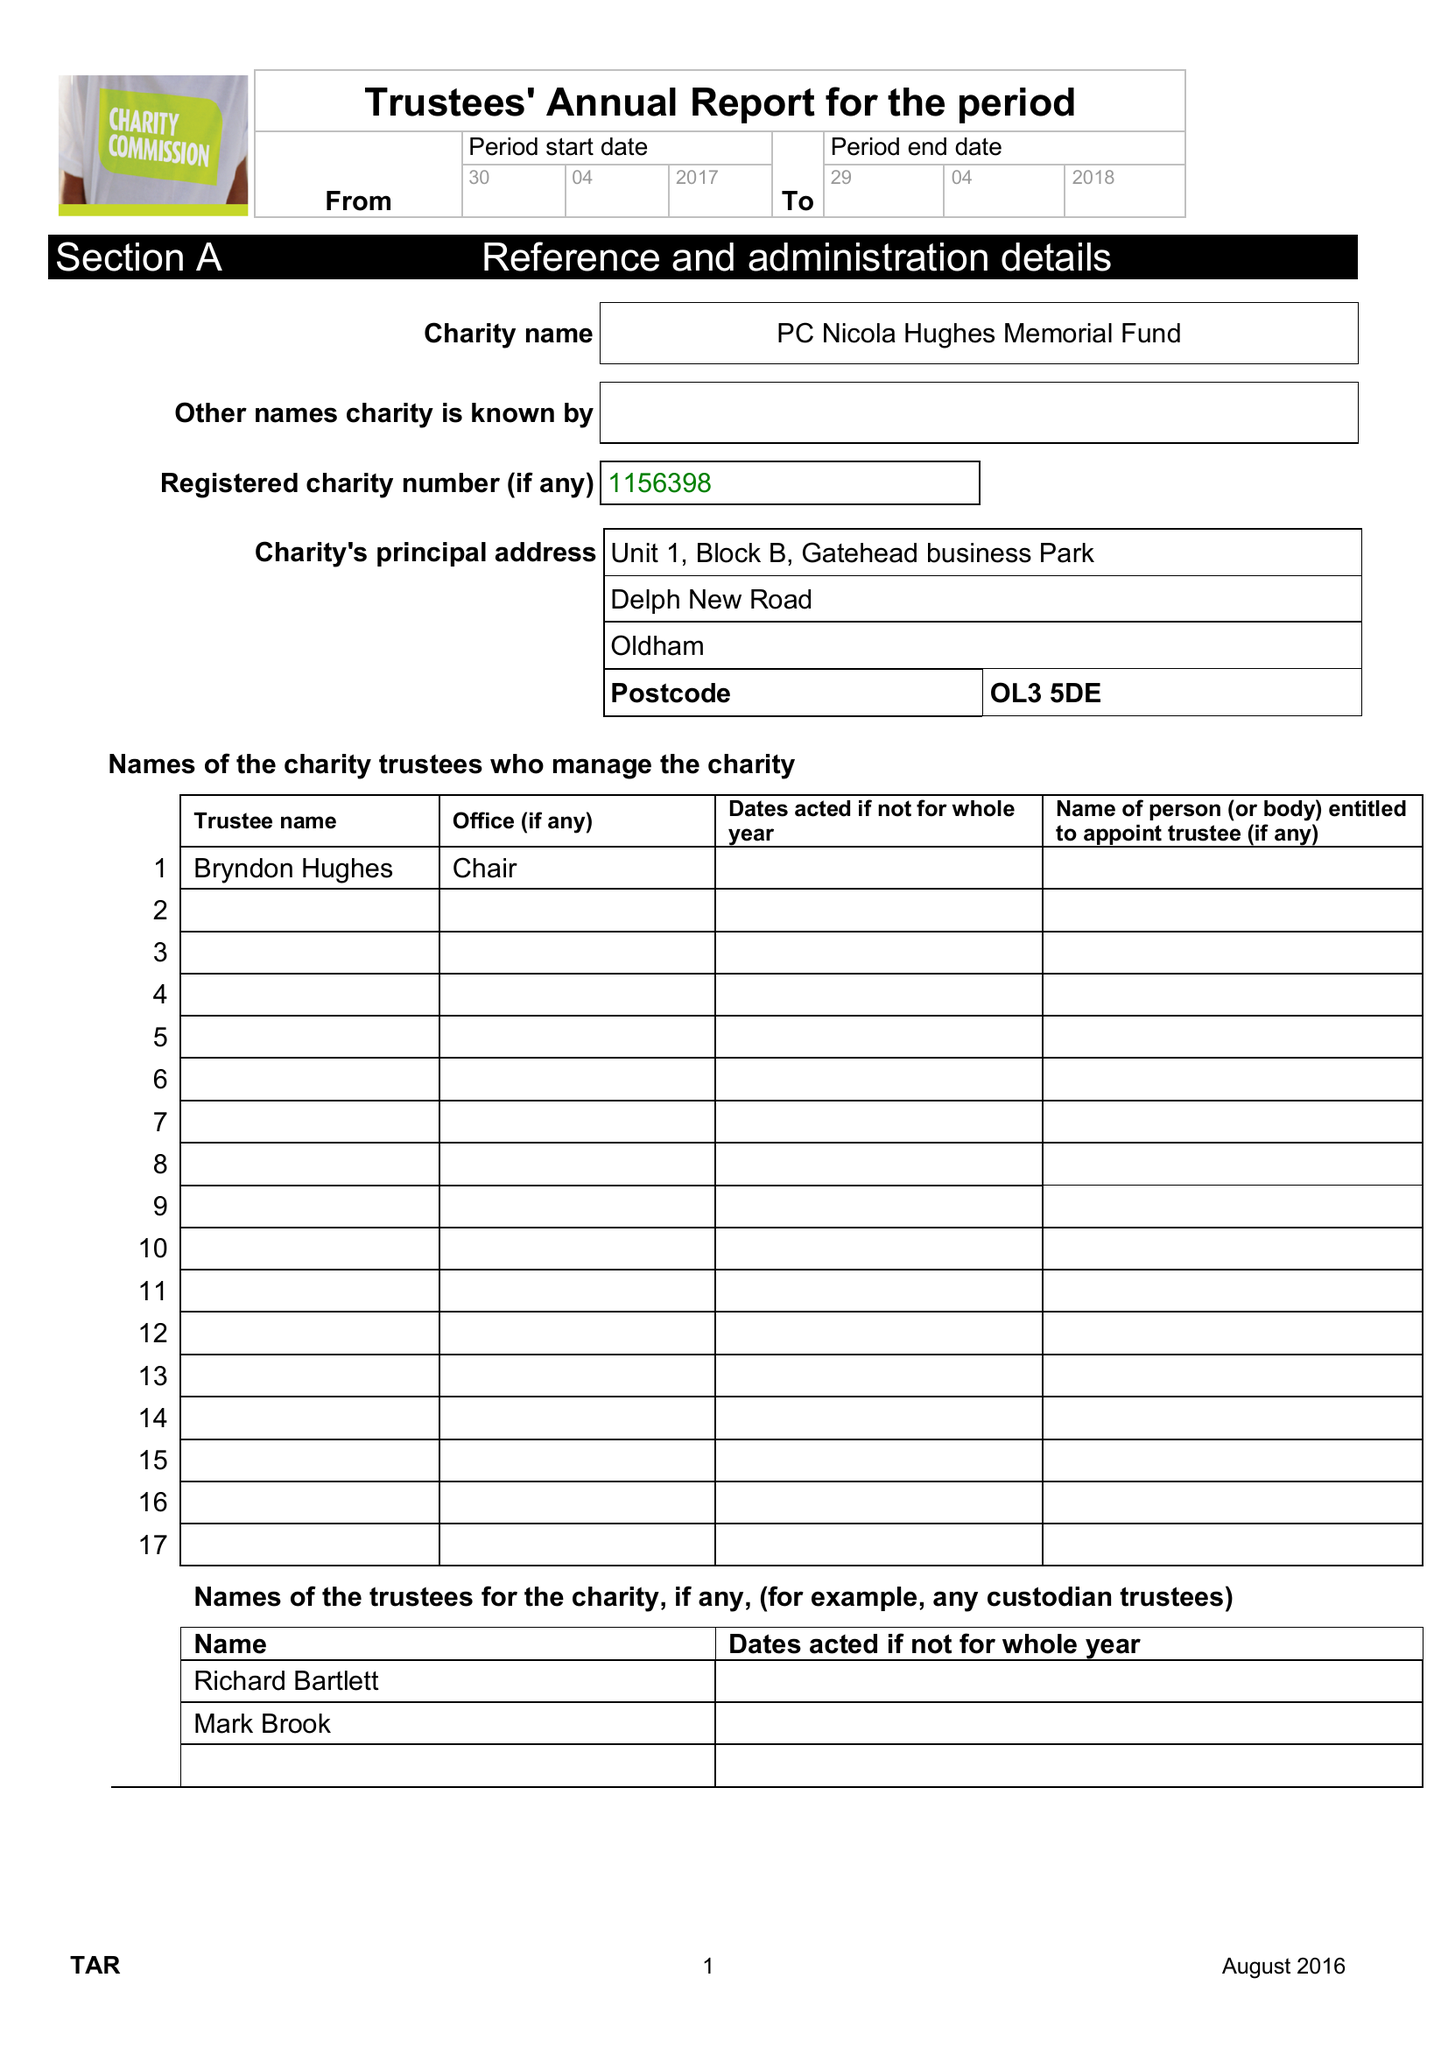What is the value for the charity_number?
Answer the question using a single word or phrase. 1156398 